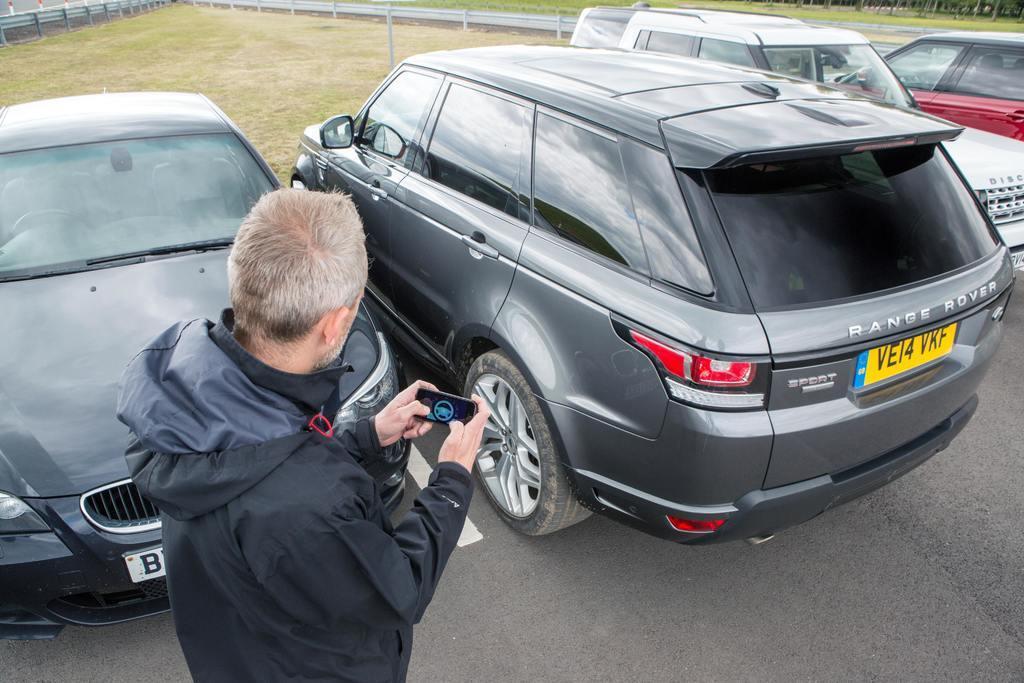Can you describe this image briefly? In this picture we can see a man holding a device with his hands, vehicles on the road, grass and in the background we can see some objects. 